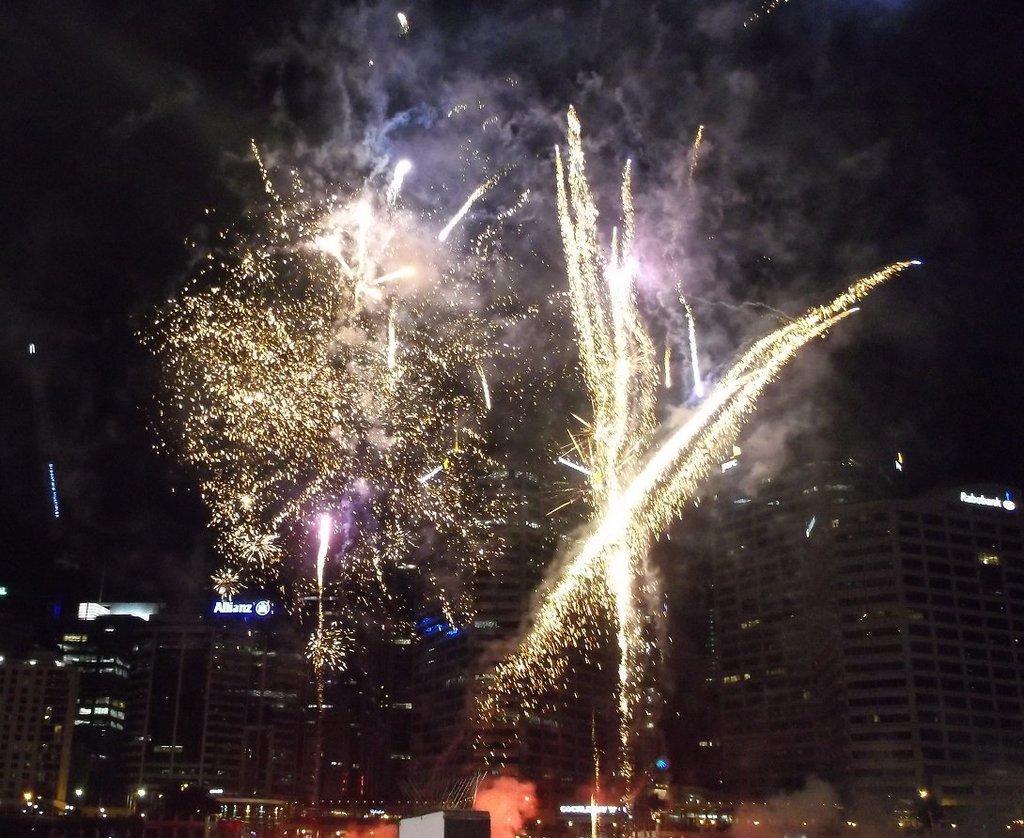Describe this image in one or two sentences. In the image we can see buildings and windows of the building. These are the crackers, this is a smoke and a sky. 